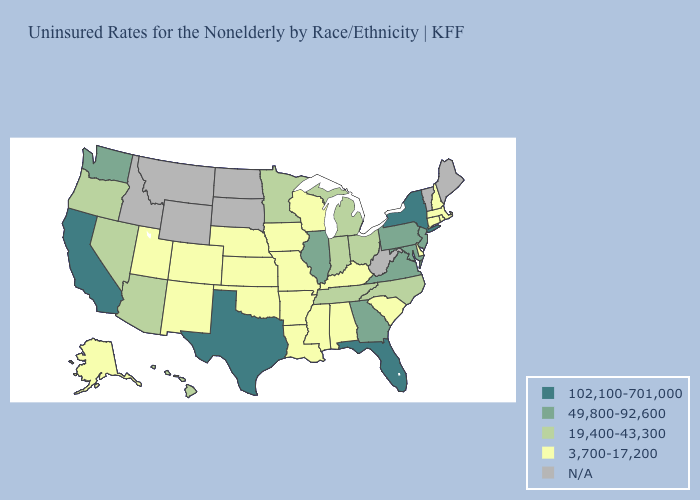Name the states that have a value in the range 49,800-92,600?
Write a very short answer. Georgia, Illinois, Maryland, New Jersey, Pennsylvania, Virginia, Washington. What is the value of Iowa?
Write a very short answer. 3,700-17,200. What is the highest value in the MidWest ?
Concise answer only. 49,800-92,600. What is the lowest value in states that border Nevada?
Concise answer only. 3,700-17,200. Does the first symbol in the legend represent the smallest category?
Quick response, please. No. Which states have the lowest value in the South?
Quick response, please. Alabama, Arkansas, Delaware, Kentucky, Louisiana, Mississippi, Oklahoma, South Carolina. What is the highest value in states that border Kentucky?
Give a very brief answer. 49,800-92,600. What is the lowest value in the Northeast?
Concise answer only. 3,700-17,200. What is the value of Oklahoma?
Concise answer only. 3,700-17,200. What is the value of Hawaii?
Be succinct. 19,400-43,300. What is the value of Alaska?
Write a very short answer. 3,700-17,200. Does the map have missing data?
Quick response, please. Yes. Name the states that have a value in the range N/A?
Short answer required. Idaho, Maine, Montana, North Dakota, South Dakota, Vermont, West Virginia, Wyoming. Does Massachusetts have the highest value in the Northeast?
Give a very brief answer. No. 